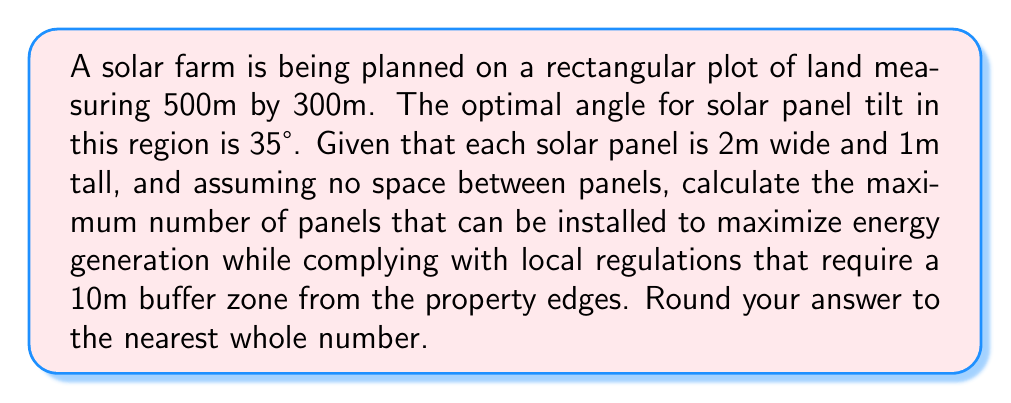Can you answer this question? 1. Calculate the usable area:
   - Total area: $500m \times 300m = 150,000m^2$
   - Buffer zone area: $(500m \times 10m \times 2) + (280m \times 10m \times 2) = 15,600m^2$
   - Usable area: $150,000m^2 - 15,600m^2 = 134,400m^2$

2. Calculate the effective area of each panel when tilted:
   - Panel width remains 2m
   - Effective panel height: $1m \times \cos(35°) \approx 0.8192m$
   - Effective area per panel: $2m \times 0.8192m \approx 1.6384m^2$

3. Calculate the number of panels:
   $$\text{Number of panels} = \frac{\text{Usable area}}{\text{Effective area per panel}}$$
   $$\text{Number of panels} = \frac{134,400m^2}{1.6384m^2} \approx 82,031.25$$

4. Round to the nearest whole number:
   $82,031$
Answer: 82,031 panels 